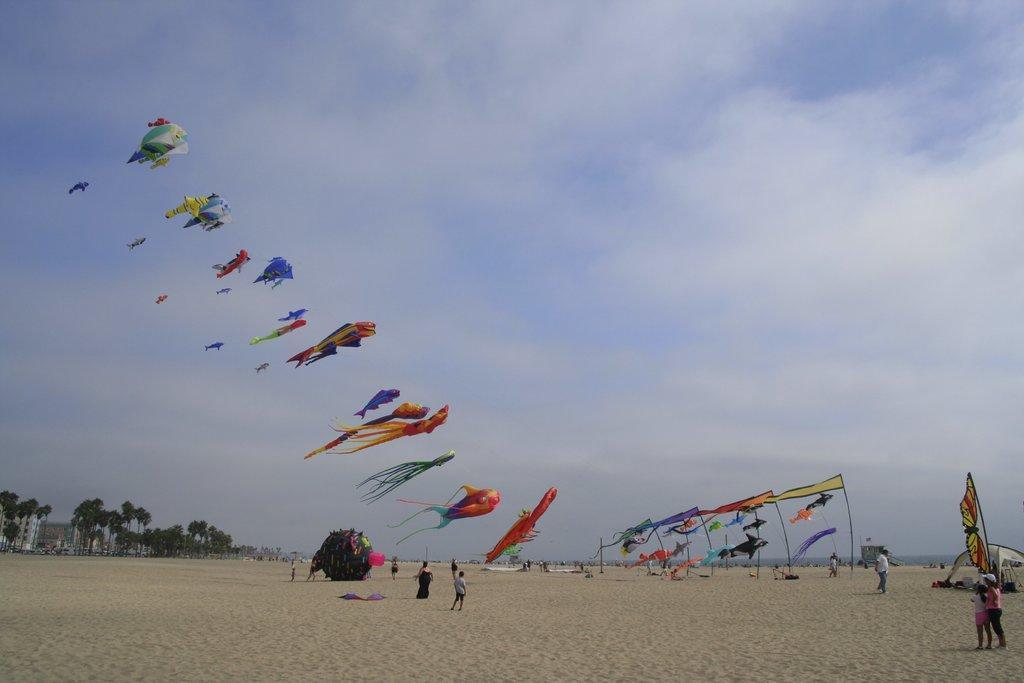Can you describe this image briefly? In this image I can see the ground, few persons standing on the ground and few flags. I can see few kites flying in the air and in the background I can see few trees, few buildings and the sky. 